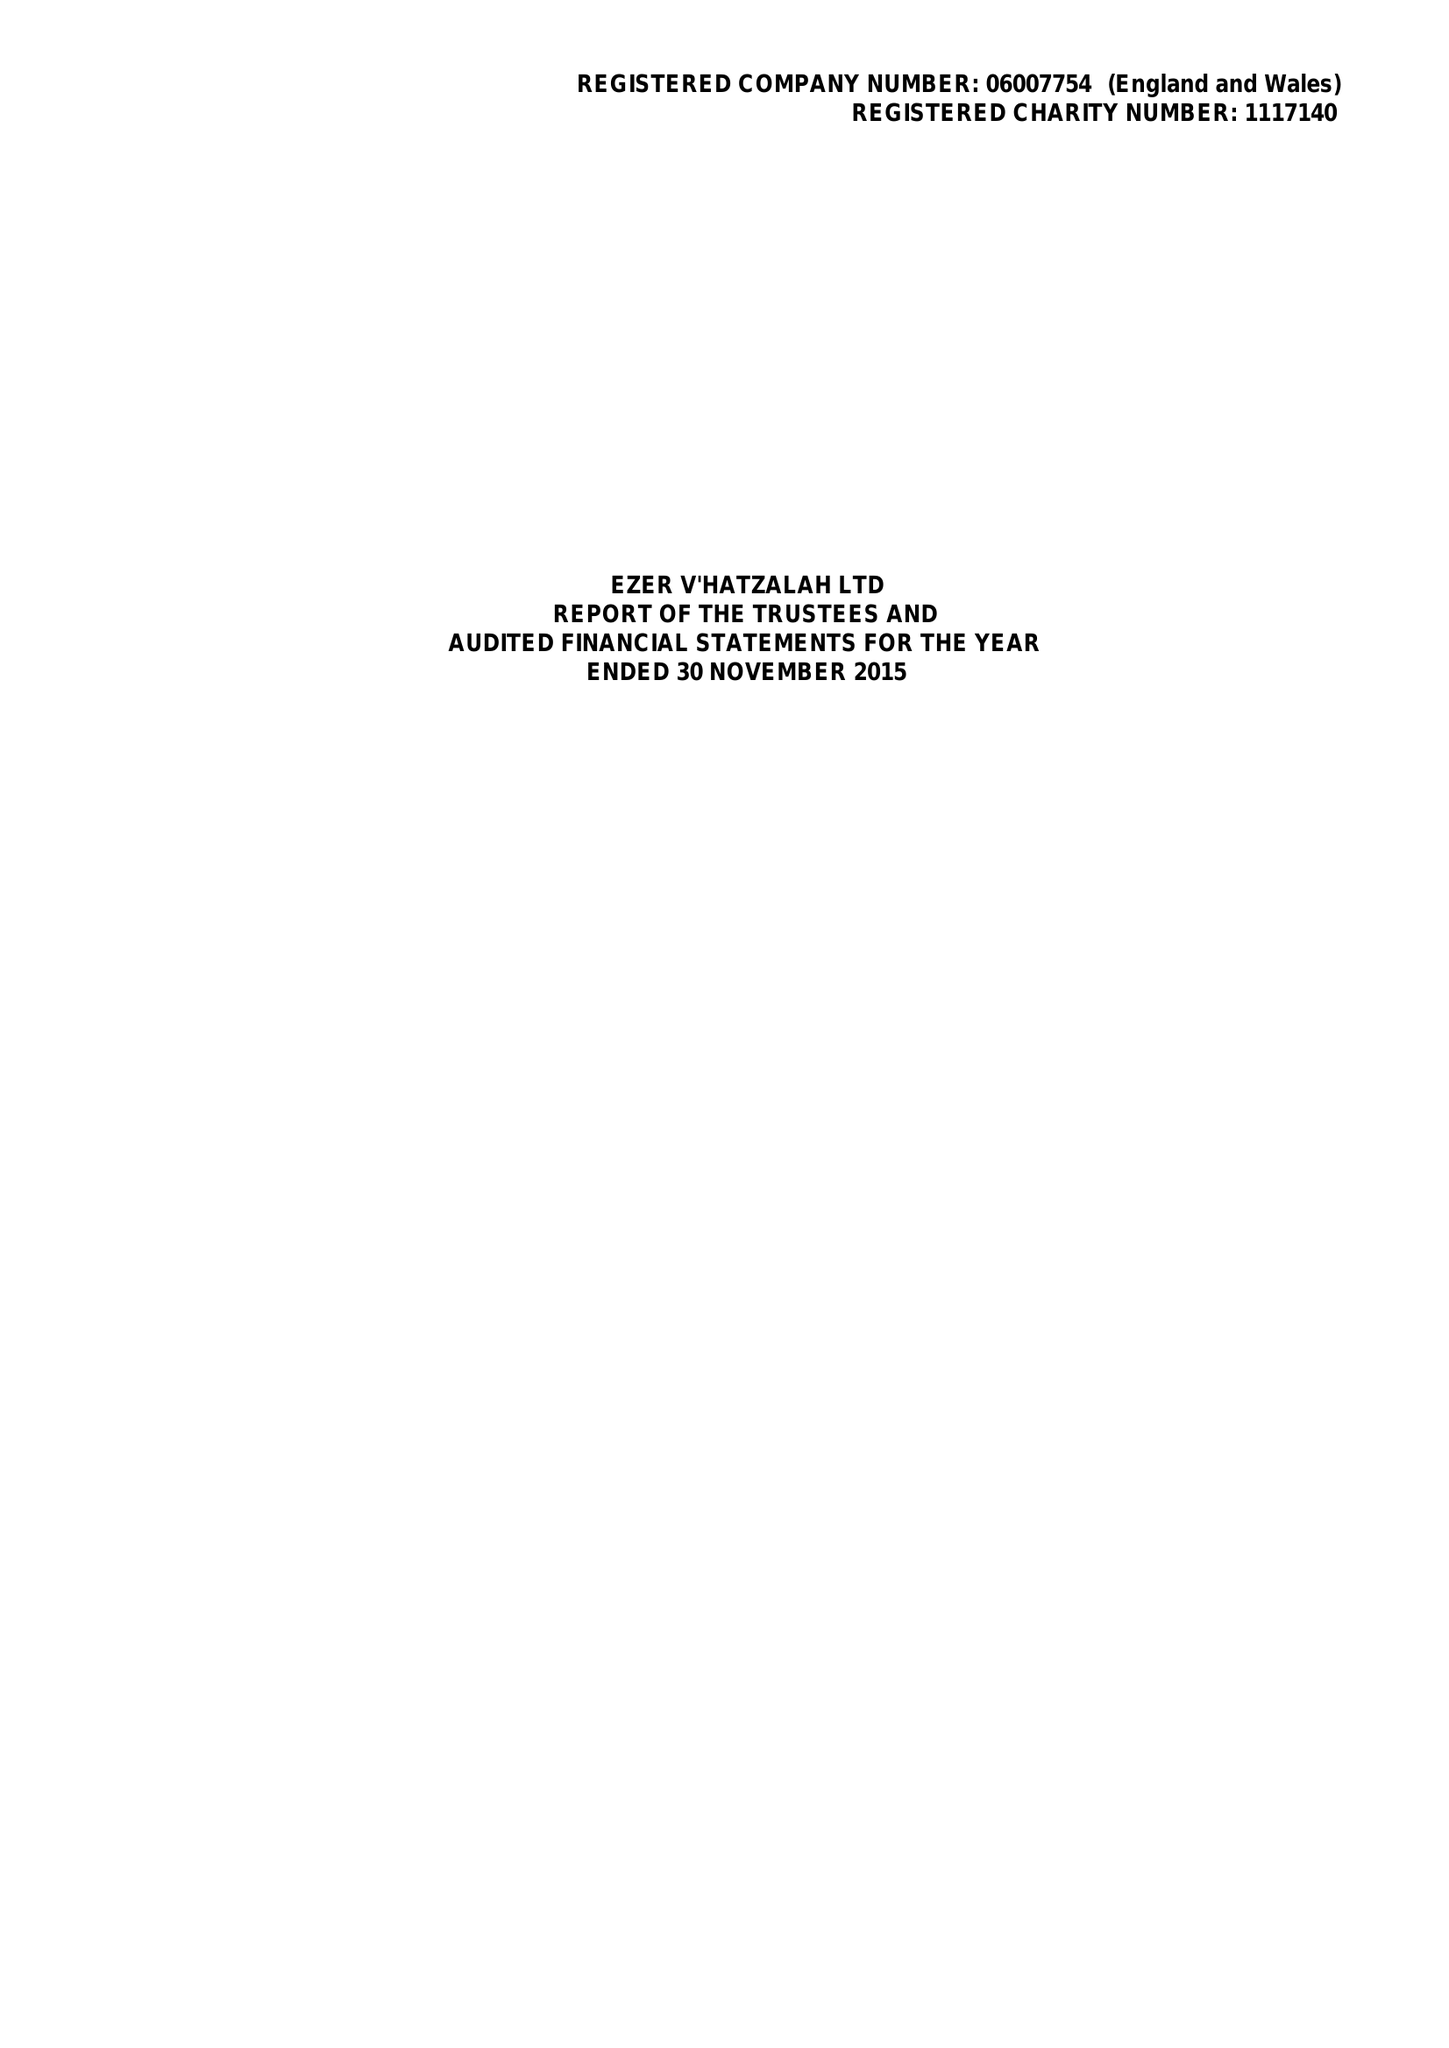What is the value for the address__street_line?
Answer the question using a single word or phrase. 52 EAST BANK 